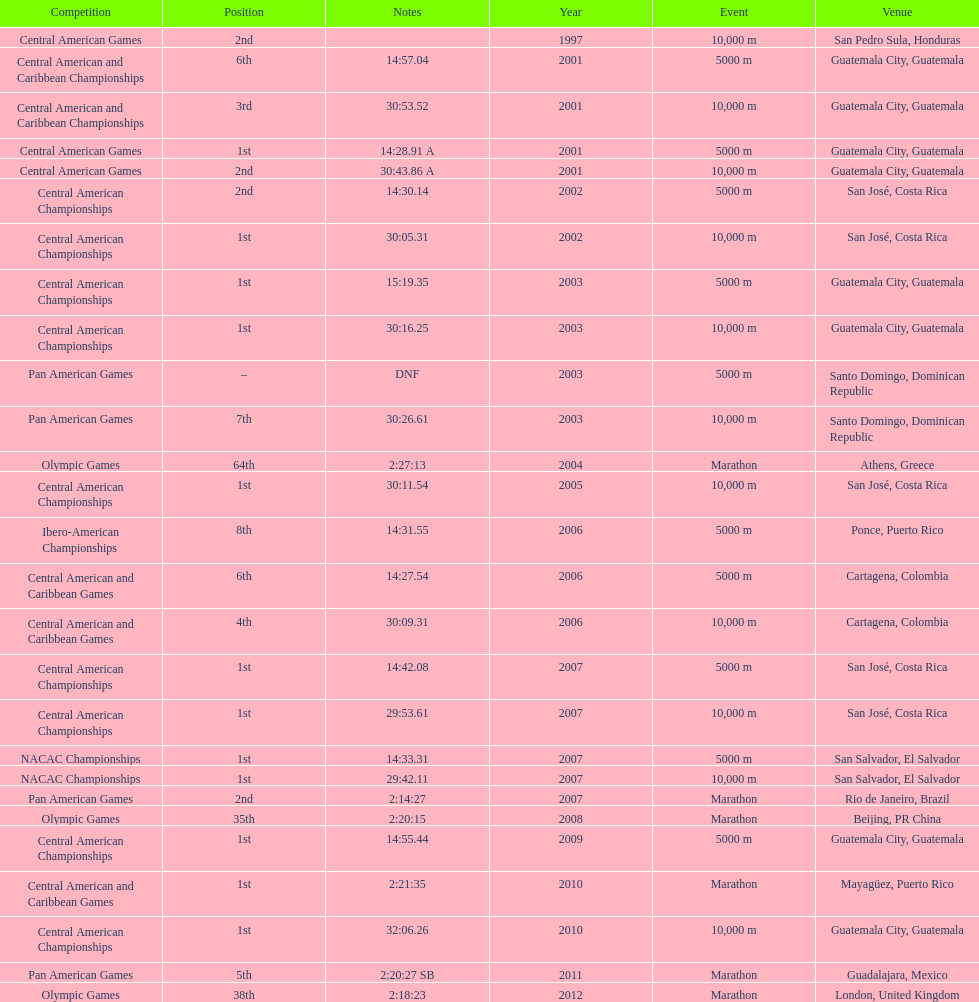What was the first competition this competitor competed in? Central American Games. Help me parse the entirety of this table. {'header': ['Competition', 'Position', 'Notes', 'Year', 'Event', 'Venue'], 'rows': [['Central American Games', '2nd', '', '1997', '10,000 m', 'San Pedro Sula, Honduras'], ['Central American and Caribbean Championships', '6th', '14:57.04', '2001', '5000 m', 'Guatemala City, Guatemala'], ['Central American and Caribbean Championships', '3rd', '30:53.52', '2001', '10,000 m', 'Guatemala City, Guatemala'], ['Central American Games', '1st', '14:28.91 A', '2001', '5000 m', 'Guatemala City, Guatemala'], ['Central American Games', '2nd', '30:43.86 A', '2001', '10,000 m', 'Guatemala City, Guatemala'], ['Central American Championships', '2nd', '14:30.14', '2002', '5000 m', 'San José, Costa Rica'], ['Central American Championships', '1st', '30:05.31', '2002', '10,000 m', 'San José, Costa Rica'], ['Central American Championships', '1st', '15:19.35', '2003', '5000 m', 'Guatemala City, Guatemala'], ['Central American Championships', '1st', '30:16.25', '2003', '10,000 m', 'Guatemala City, Guatemala'], ['Pan American Games', '–', 'DNF', '2003', '5000 m', 'Santo Domingo, Dominican Republic'], ['Pan American Games', '7th', '30:26.61', '2003', '10,000 m', 'Santo Domingo, Dominican Republic'], ['Olympic Games', '64th', '2:27:13', '2004', 'Marathon', 'Athens, Greece'], ['Central American Championships', '1st', '30:11.54', '2005', '10,000 m', 'San José, Costa Rica'], ['Ibero-American Championships', '8th', '14:31.55', '2006', '5000 m', 'Ponce, Puerto Rico'], ['Central American and Caribbean Games', '6th', '14:27.54', '2006', '5000 m', 'Cartagena, Colombia'], ['Central American and Caribbean Games', '4th', '30:09.31', '2006', '10,000 m', 'Cartagena, Colombia'], ['Central American Championships', '1st', '14:42.08', '2007', '5000 m', 'San José, Costa Rica'], ['Central American Championships', '1st', '29:53.61', '2007', '10,000 m', 'San José, Costa Rica'], ['NACAC Championships', '1st', '14:33.31', '2007', '5000 m', 'San Salvador, El Salvador'], ['NACAC Championships', '1st', '29:42.11', '2007', '10,000 m', 'San Salvador, El Salvador'], ['Pan American Games', '2nd', '2:14:27', '2007', 'Marathon', 'Rio de Janeiro, Brazil'], ['Olympic Games', '35th', '2:20:15', '2008', 'Marathon', 'Beijing, PR China'], ['Central American Championships', '1st', '14:55.44', '2009', '5000 m', 'Guatemala City, Guatemala'], ['Central American and Caribbean Games', '1st', '2:21:35', '2010', 'Marathon', 'Mayagüez, Puerto Rico'], ['Central American Championships', '1st', '32:06.26', '2010', '10,000 m', 'Guatemala City, Guatemala'], ['Pan American Games', '5th', '2:20:27 SB', '2011', 'Marathon', 'Guadalajara, Mexico'], ['Olympic Games', '38th', '2:18:23', '2012', 'Marathon', 'London, United Kingdom']]} 